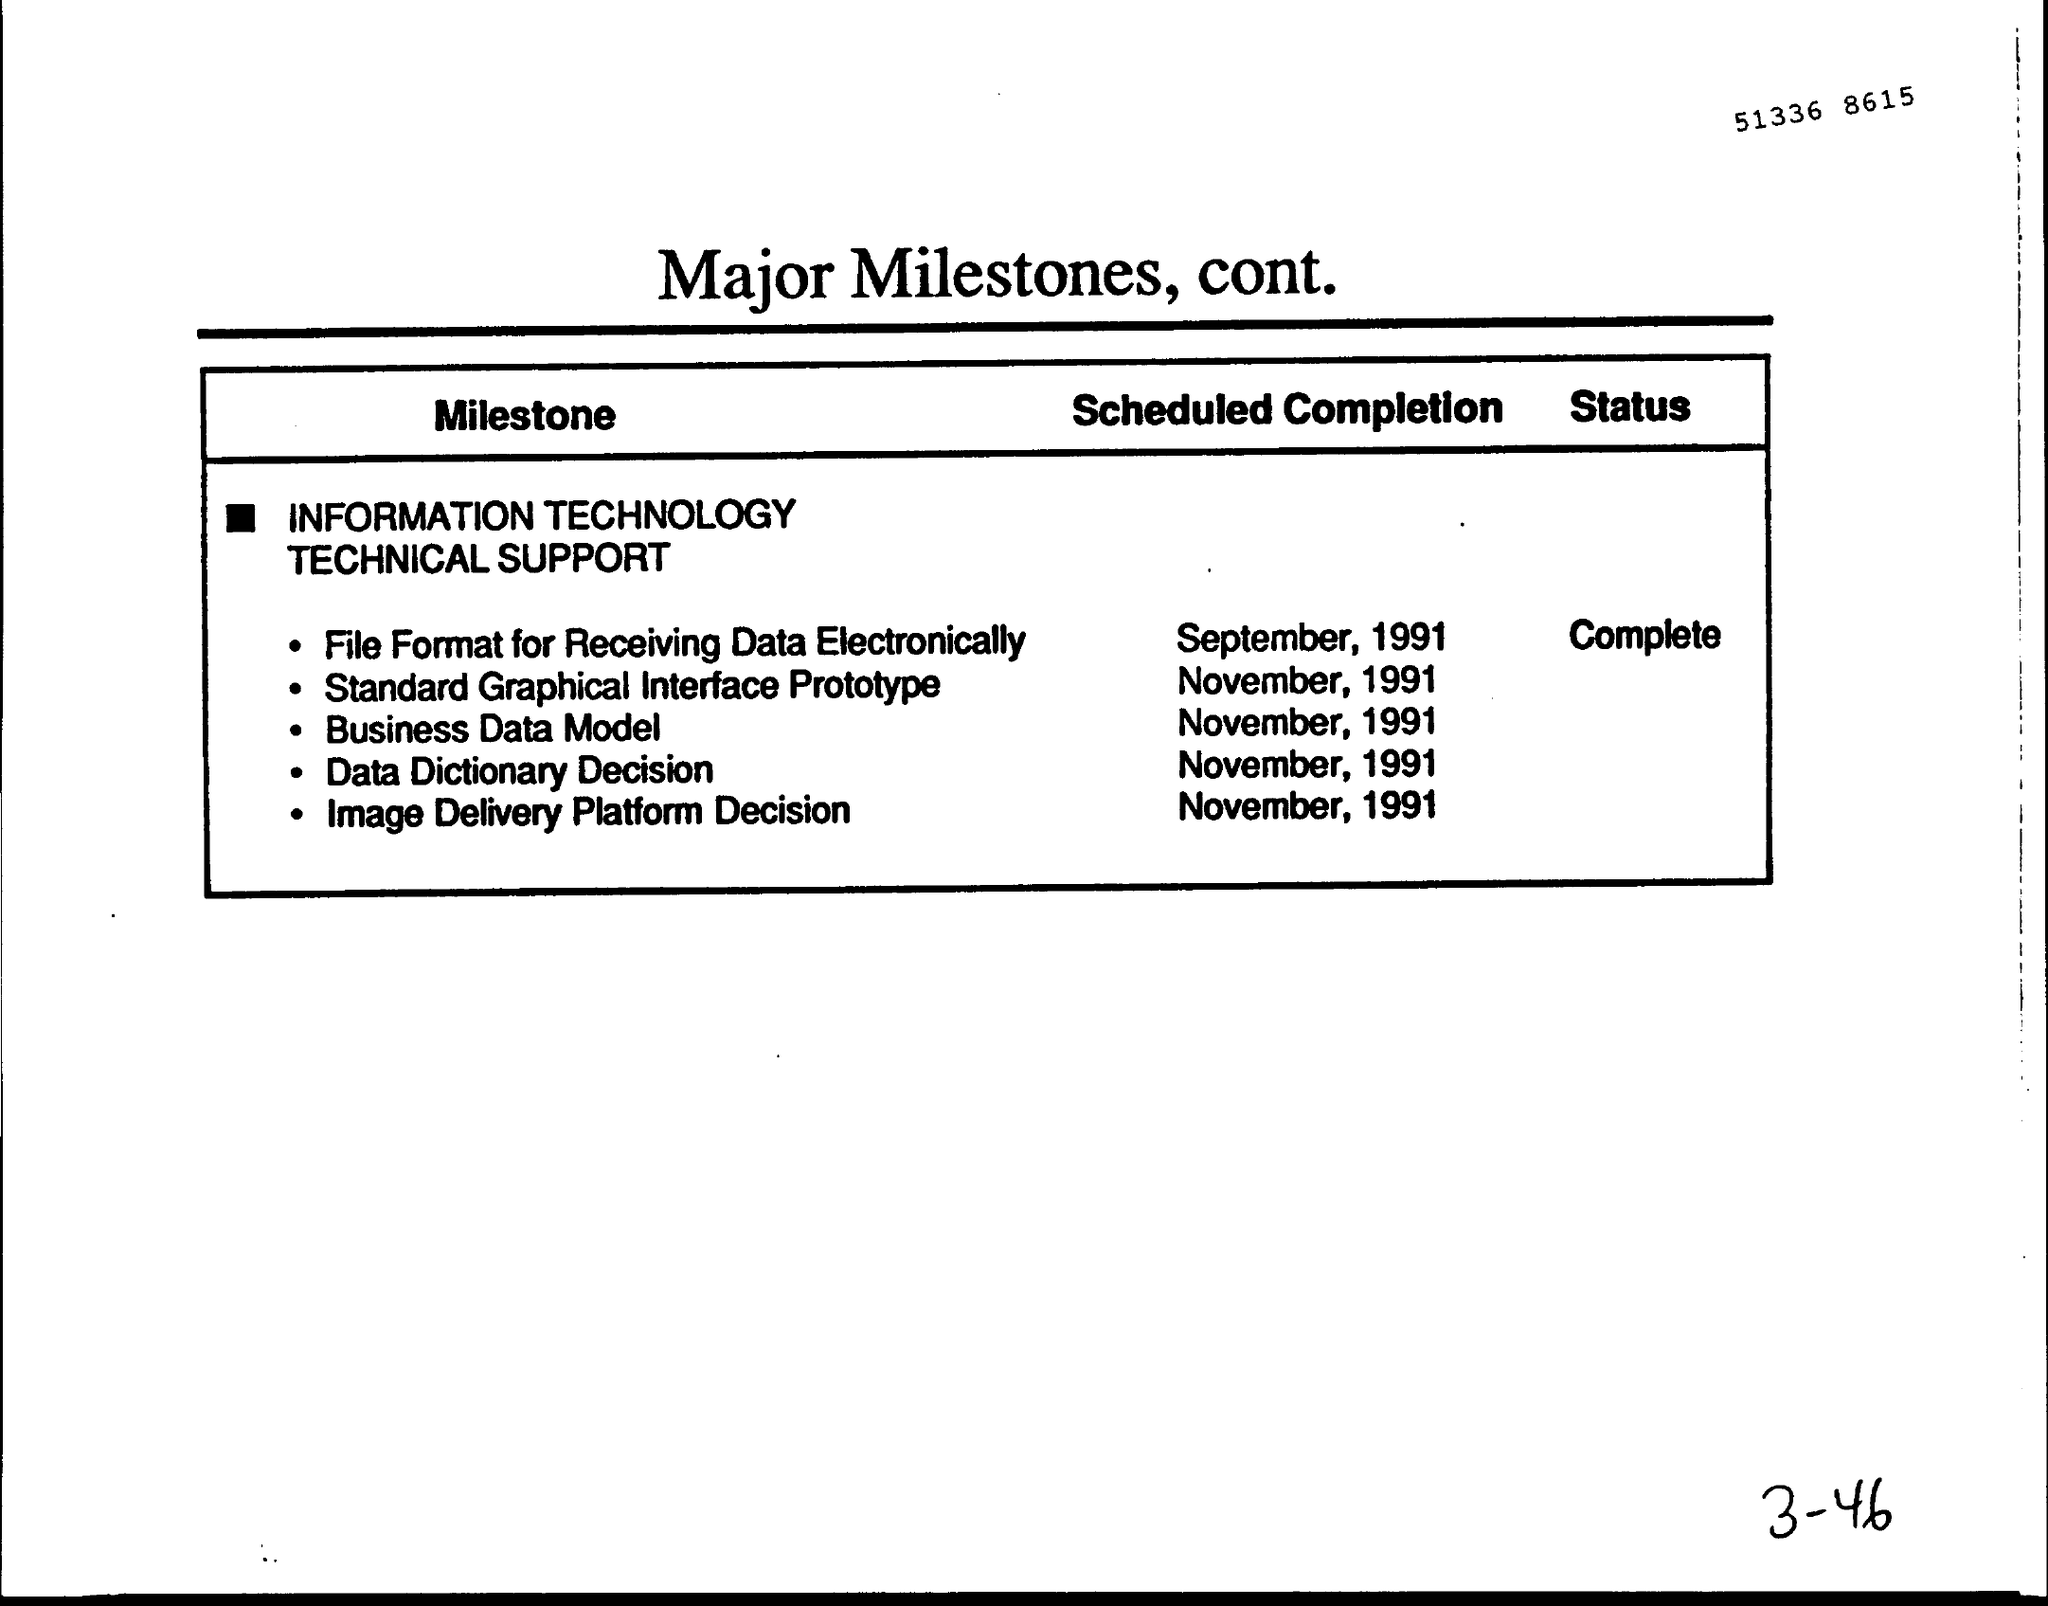Outline some significant characteristics in this image. The scheduled completion date for the Image Delivery Platform Decision project was November, 1991. The scheduled completion date for the standard graphical interface prototype was set for November, 1991. The "Scheduled Completion" for the "Data dictionary Decision" was expected to be completed by November, 1991. The title of the document is "Major Milestones, Continued. The "Scheduled Completion" for the "Business Data Model" was expected to be in November, 1991. 